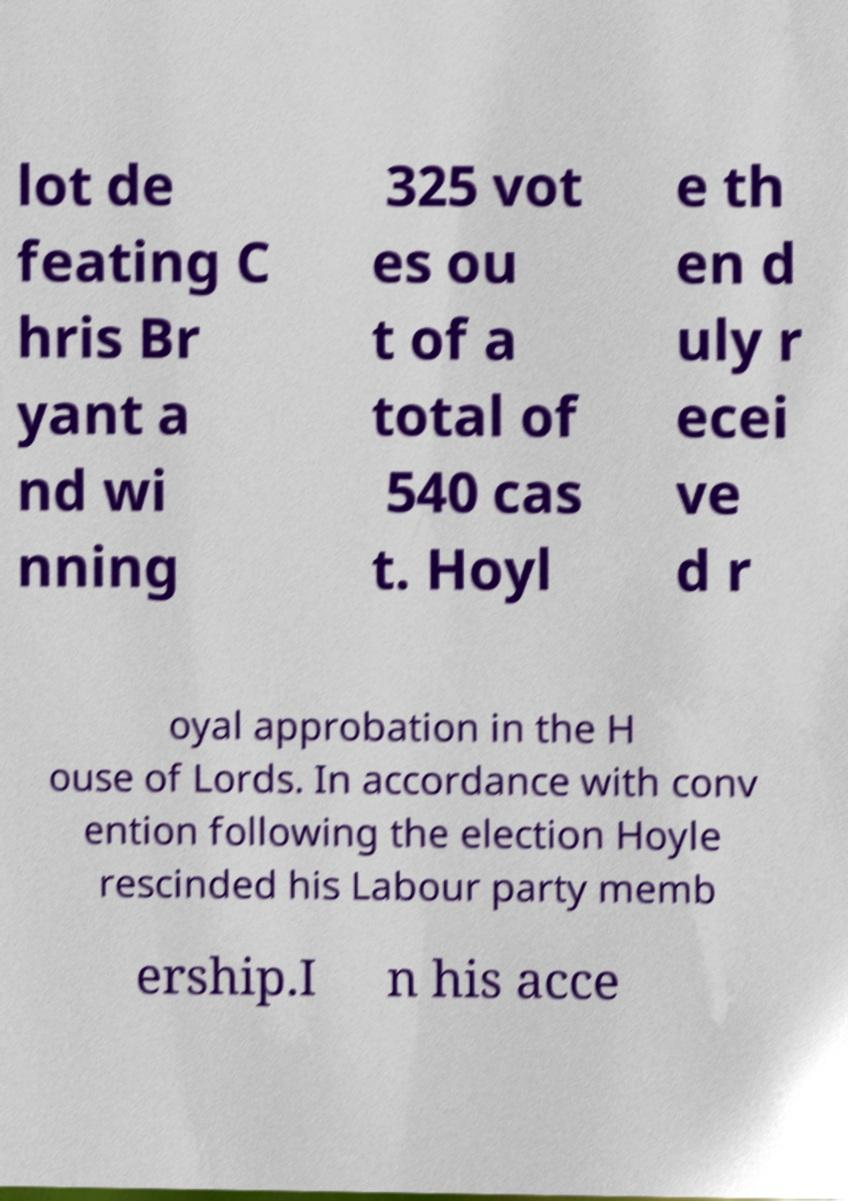There's text embedded in this image that I need extracted. Can you transcribe it verbatim? lot de feating C hris Br yant a nd wi nning 325 vot es ou t of a total of 540 cas t. Hoyl e th en d uly r ecei ve d r oyal approbation in the H ouse of Lords. In accordance with conv ention following the election Hoyle rescinded his Labour party memb ership.I n his acce 